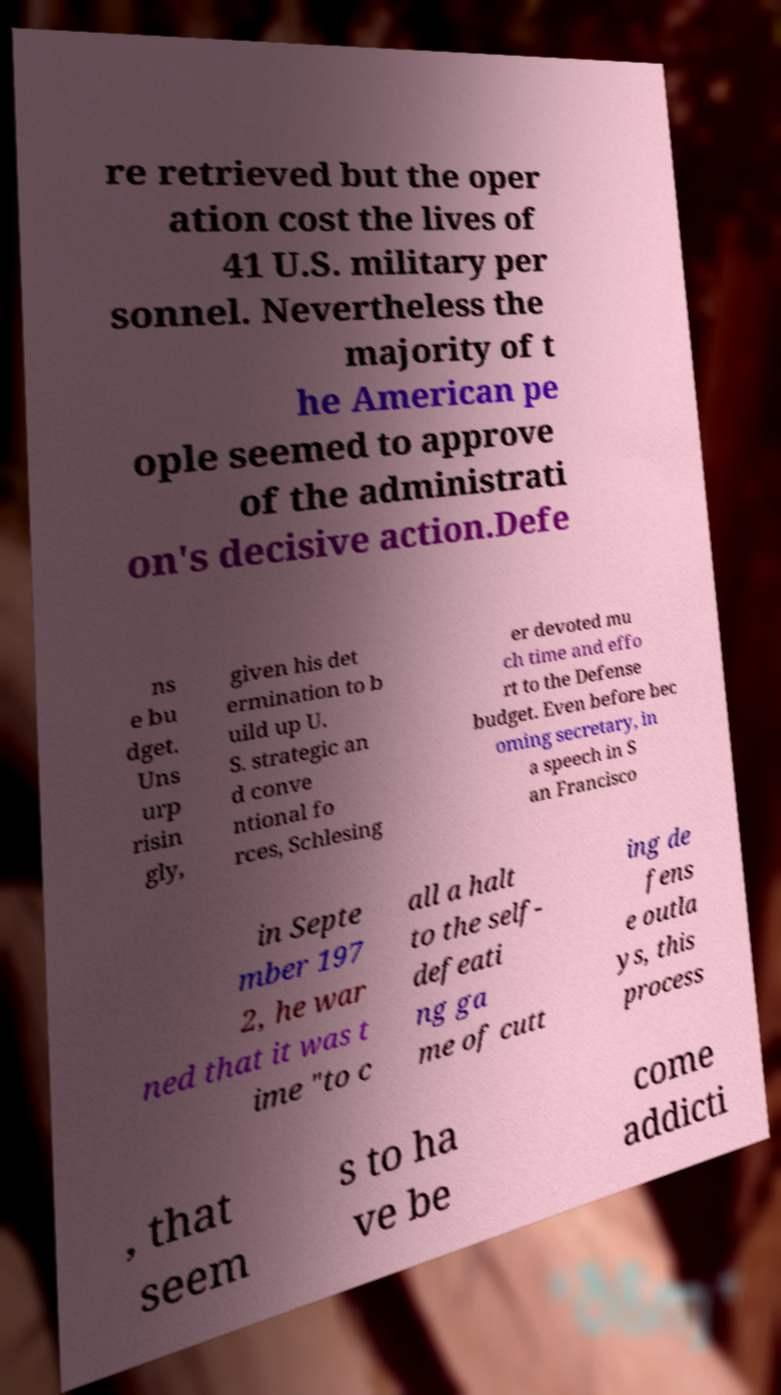Please read and relay the text visible in this image. What does it say? re retrieved but the oper ation cost the lives of 41 U.S. military per sonnel. Nevertheless the majority of t he American pe ople seemed to approve of the administrati on's decisive action.Defe ns e bu dget. Uns urp risin gly, given his det ermination to b uild up U. S. strategic an d conve ntional fo rces, Schlesing er devoted mu ch time and effo rt to the Defense budget. Even before bec oming secretary, in a speech in S an Francisco in Septe mber 197 2, he war ned that it was t ime "to c all a halt to the self- defeati ng ga me of cutt ing de fens e outla ys, this process , that seem s to ha ve be come addicti 